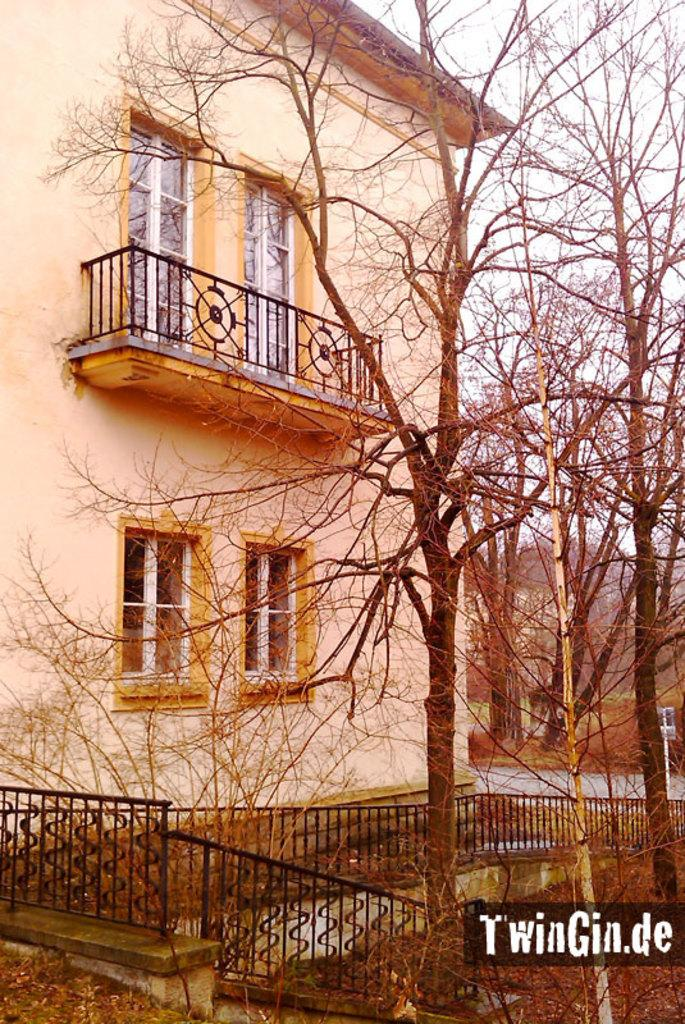What type of material is the railing in the image made of? The railing in the image is made of steel. What is the condition of the trees in the image? The trees in the image are dry. What can be seen in the background of the image? There is a building and the sky visible in the background of the image. Where is the watermark located in the image? The watermark is at the bottom right side of the image. What type of drug can be seen in the image? There is no drug present in the image. What color is the eye in the image? There is no eye present in the image. 